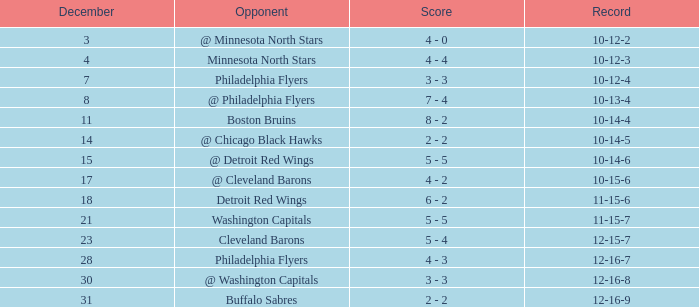What is the lowest December, when Score is "4 - 4"? 4.0. 